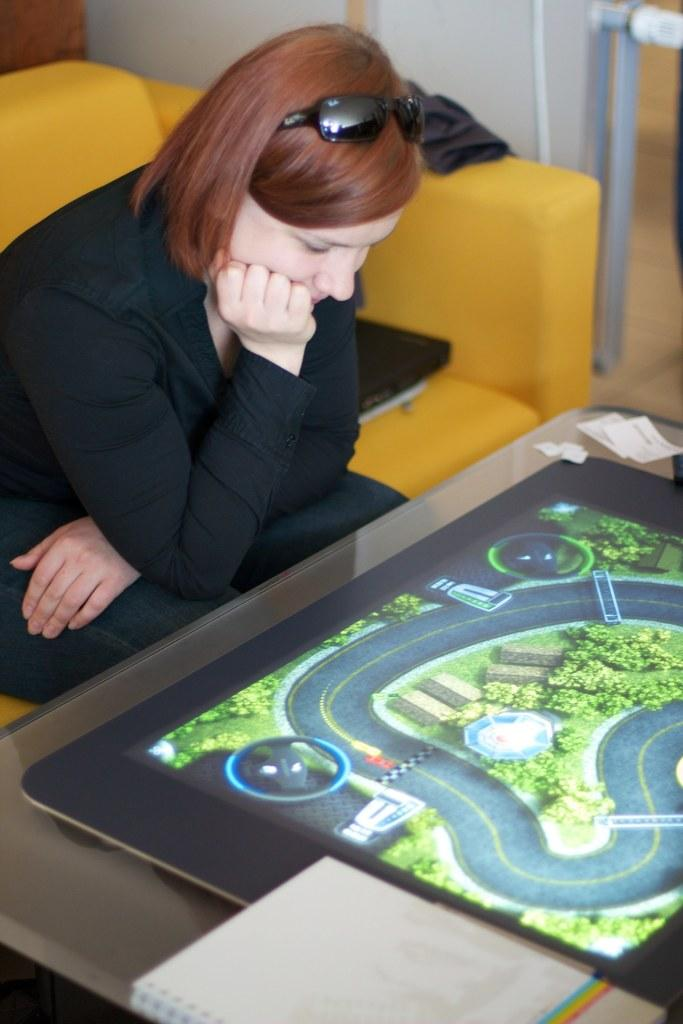Who is present in the image? There is a woman in the image. What is the woman sitting on? The woman is sitting on a yellow sofa. What is in front of the woman? There is a table in front of the woman. What is on the table? There is a game on the table. Can you find any reading material in the image? Yes, there is a book in the image. What type of marble is visible on the sidewalk outside the window in the image? There is no mention of a window or a sidewalk in the image, and no marble is visible. 